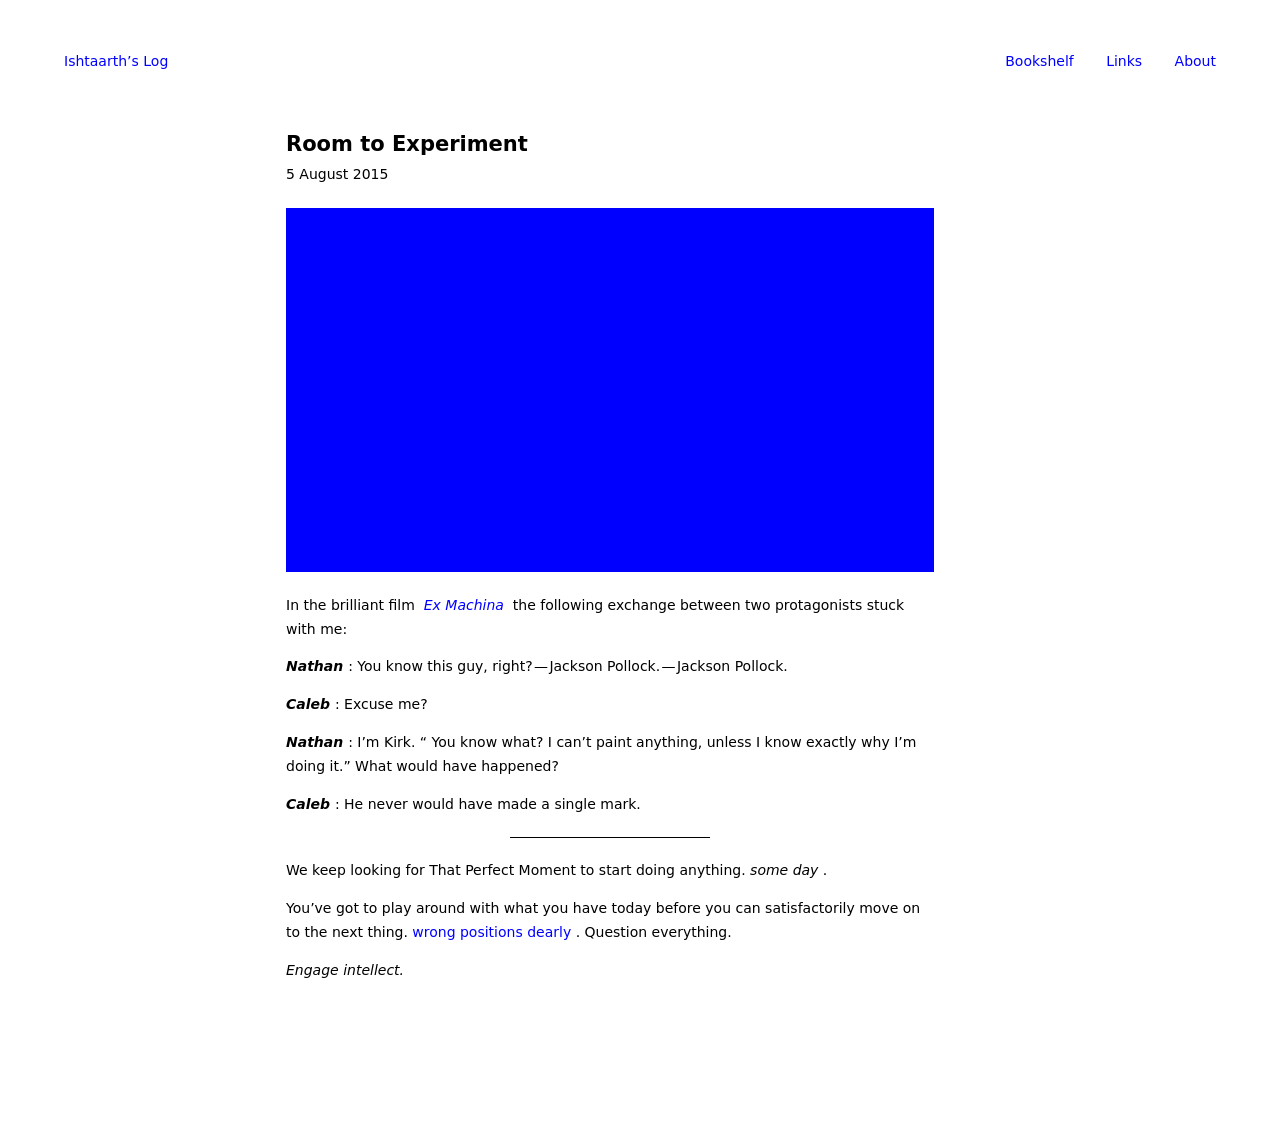What kind of content would complement the design showcased in the blue square for a creative blog or personal website? For a creative blog or personal website utilizing a design like the blue square, the content should be equally sleek and straightforward. Focus on high-quality visuals and succinct text. For instance, a photography blog could feature striking images with minimal text to allow the visuals to speak more. A personal website could include stream-lined, professional biographies, a portfolio of work, and perhaps a concise blog section that shares insights or personal updates using engaging media and straightforward language. 